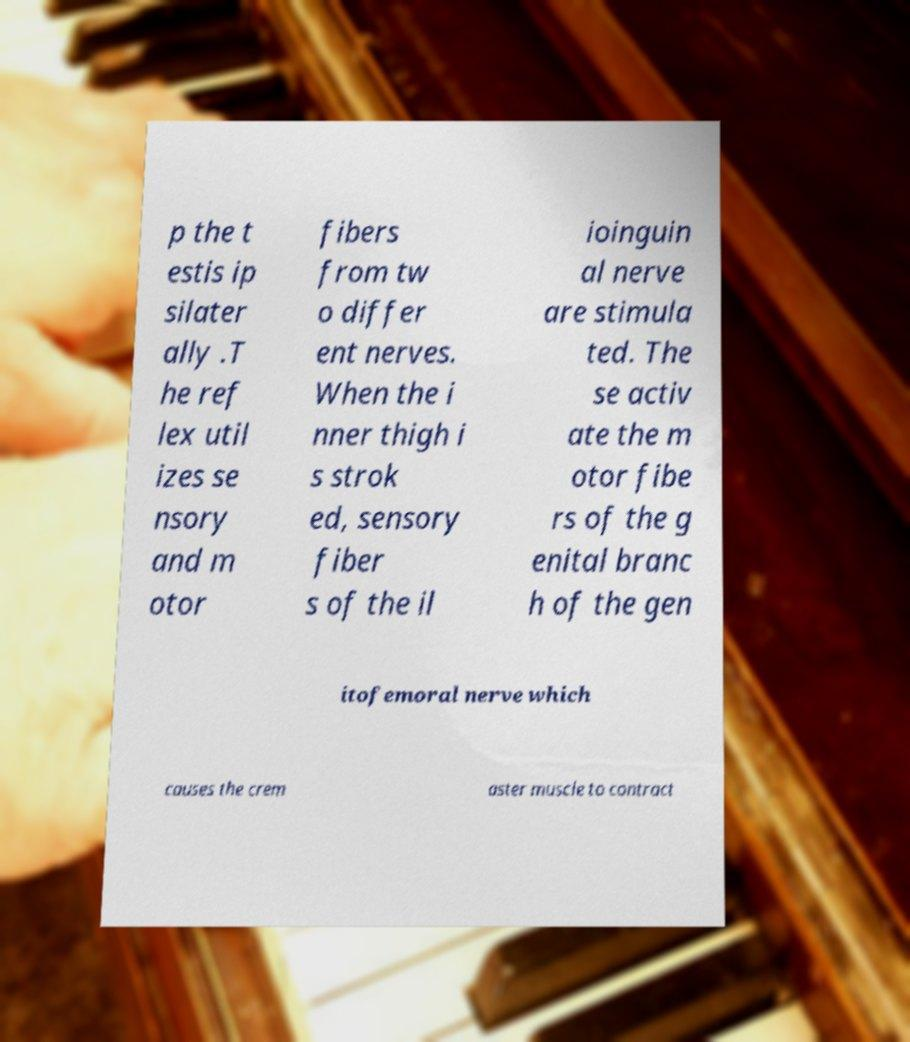There's text embedded in this image that I need extracted. Can you transcribe it verbatim? p the t estis ip silater ally .T he ref lex util izes se nsory and m otor fibers from tw o differ ent nerves. When the i nner thigh i s strok ed, sensory fiber s of the il ioinguin al nerve are stimula ted. The se activ ate the m otor fibe rs of the g enital branc h of the gen itofemoral nerve which causes the crem aster muscle to contract 